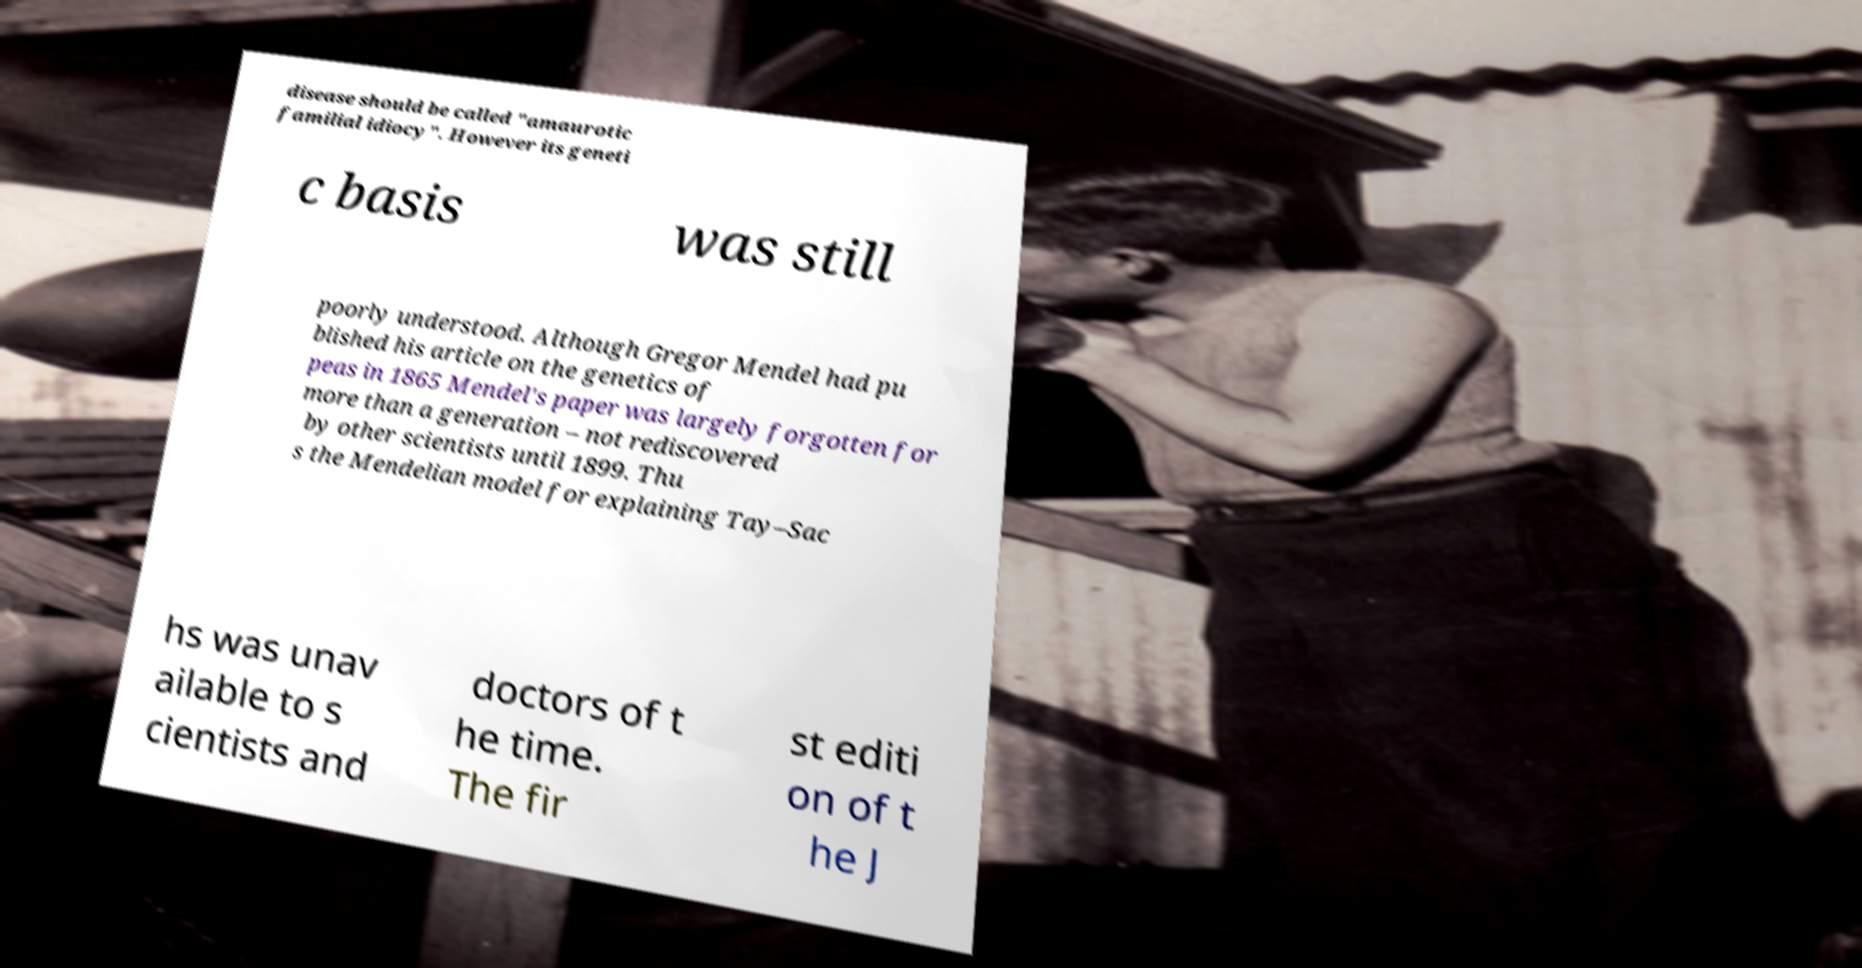For documentation purposes, I need the text within this image transcribed. Could you provide that? disease should be called "amaurotic familial idiocy". However its geneti c basis was still poorly understood. Although Gregor Mendel had pu blished his article on the genetics of peas in 1865 Mendel's paper was largely forgotten for more than a generation – not rediscovered by other scientists until 1899. Thu s the Mendelian model for explaining Tay–Sac hs was unav ailable to s cientists and doctors of t he time. The fir st editi on of t he J 